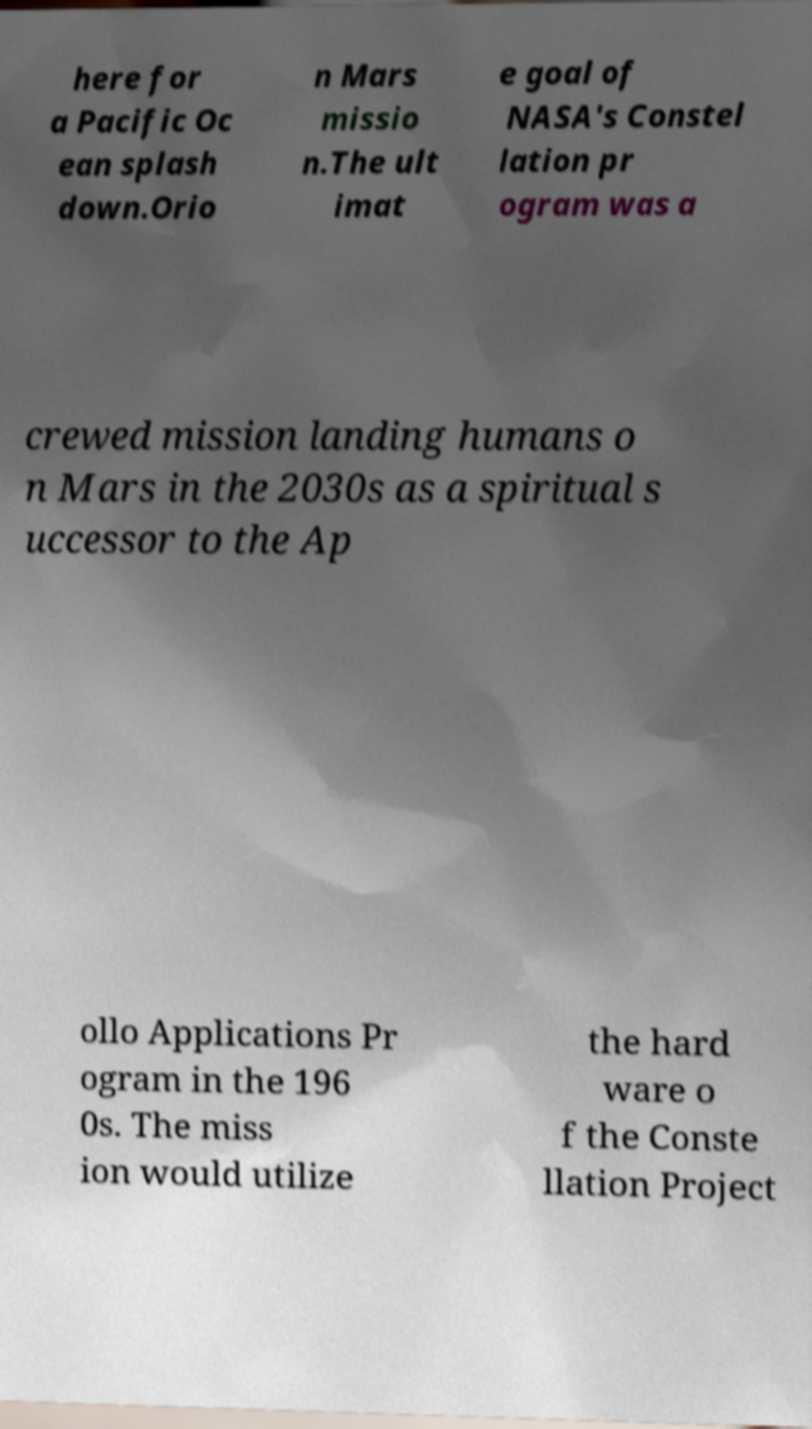Please read and relay the text visible in this image. What does it say? here for a Pacific Oc ean splash down.Orio n Mars missio n.The ult imat e goal of NASA's Constel lation pr ogram was a crewed mission landing humans o n Mars in the 2030s as a spiritual s uccessor to the Ap ollo Applications Pr ogram in the 196 0s. The miss ion would utilize the hard ware o f the Conste llation Project 